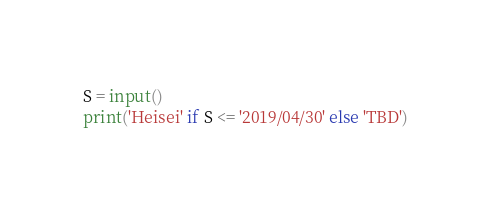Convert code to text. <code><loc_0><loc_0><loc_500><loc_500><_Python_>S = input()
print('Heisei' if S <= '2019/04/30' else 'TBD')
</code> 